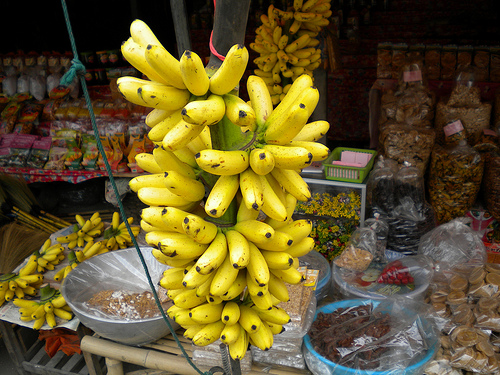Please provide the bounding box coordinate of the region this sentence describes: bananas hanged on a stick. The bananas which are suspended from a stick, providing a practical and eye-catching display, are located at the coordinates [0.49, 0.13, 0.68, 0.32]. 